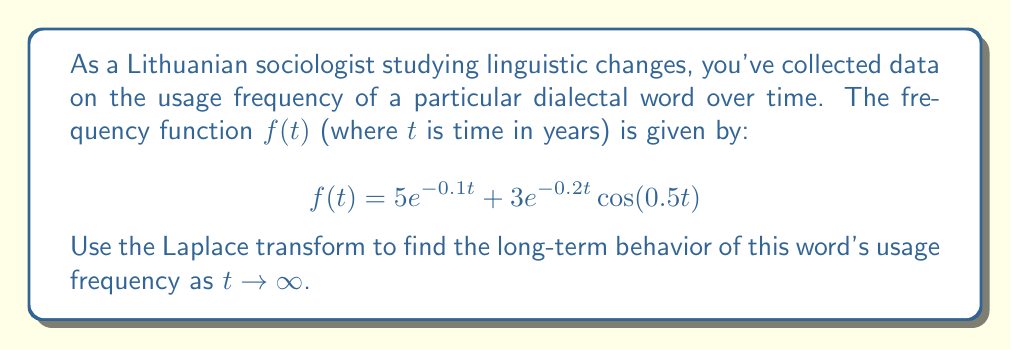Help me with this question. To analyze the long-term behavior of the word usage frequency, we can use the Final Value Theorem of Laplace transforms. This theorem states that for a function $f(t)$ with Laplace transform $F(s)$, if the limit exists:

$$\lim_{t \to \infty} f(t) = \lim_{s \to 0} sF(s)$$

Let's follow these steps:

1) First, we need to find the Laplace transform of $f(t)$. Let $F(s) = \mathcal{L}\{f(t)\}$.

2) For the first term $5e^{-0.1t}$:
   $$\mathcal{L}\{5e^{-0.1t}\} = \frac{5}{s+0.1}$$

3) For the second term $3e^{-0.2t} \cos(0.5t)$, we can use the Laplace transform of a damped cosine function:
   $$\mathcal{L}\{3e^{-0.2t} \cos(0.5t)\} = 3 \cdot \frac{s+0.2}{(s+0.2)^2 + 0.5^2}$$

4) Combining these:
   $$F(s) = \frac{5}{s+0.1} + 3 \cdot \frac{s+0.2}{(s+0.2)^2 + 0.5^2}$$

5) Now, we apply the Final Value Theorem:
   $$\lim_{t \to \infty} f(t) = \lim_{s \to 0} s \left(\frac{5}{s+0.1} + 3 \cdot \frac{s+0.2}{(s+0.2)^2 + 0.5^2}\right)$$

6) As $s \to 0$:
   $$\lim_{s \to 0} s \cdot \frac{5}{s+0.1} = \frac{5 \cdot 0}{0+0.1} = 0$$
   $$\lim_{s \to 0} s \cdot 3 \cdot \frac{s+0.2}{(s+0.2)^2 + 0.5^2} = 3 \cdot \frac{0 \cdot 0.2}{0.2^2 + 0.5^2} = 0$$

7) Therefore, the sum of these limits is also 0.

This result indicates that the usage frequency of the dialectal word approaches 0 as time goes to infinity, suggesting that the word may eventually fall out of use in the long term.
Answer: The long-term behavior of the word usage frequency as $t \to \infty$ is:

$$\lim_{t \to \infty} f(t) = 0$$

This indicates that the usage of the dialectal word will decrease over time and eventually approach zero. 